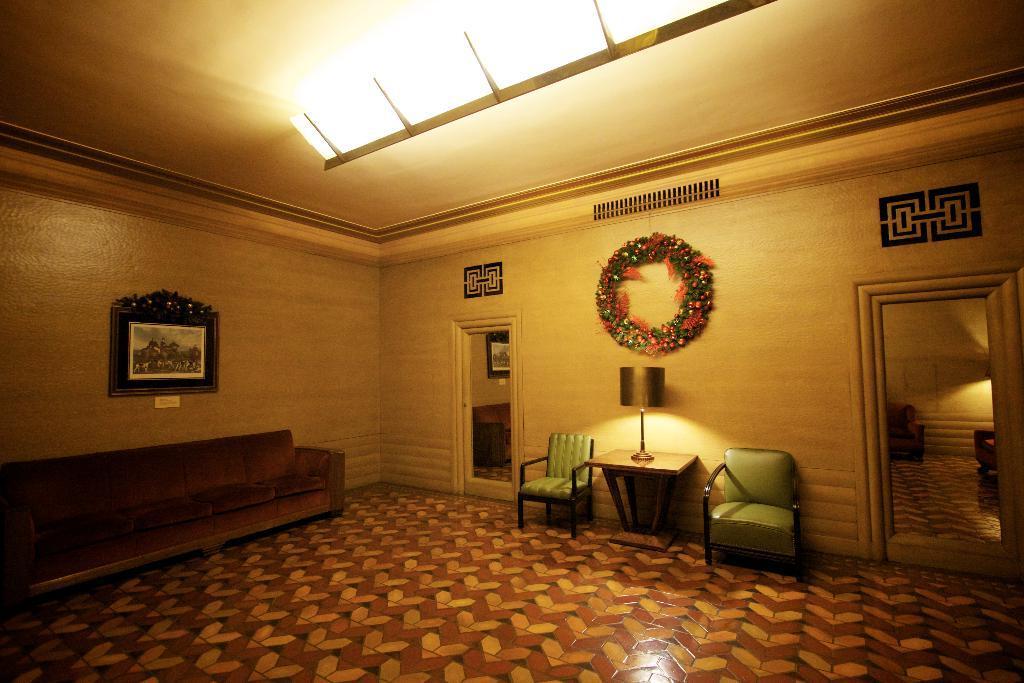In one or two sentences, can you explain what this image depicts? There is a sofa on the left side of the image. On the wall there is a photo frame. In the middle of the image there is a table, on which lamp is kept and both side of the table there is a chair. On above the lamp there is a garland stick to the wall. In the middle of the image and right side of the image bottom there are two doors. There is a roof top with light yellow and brown in color and having a light on it. 